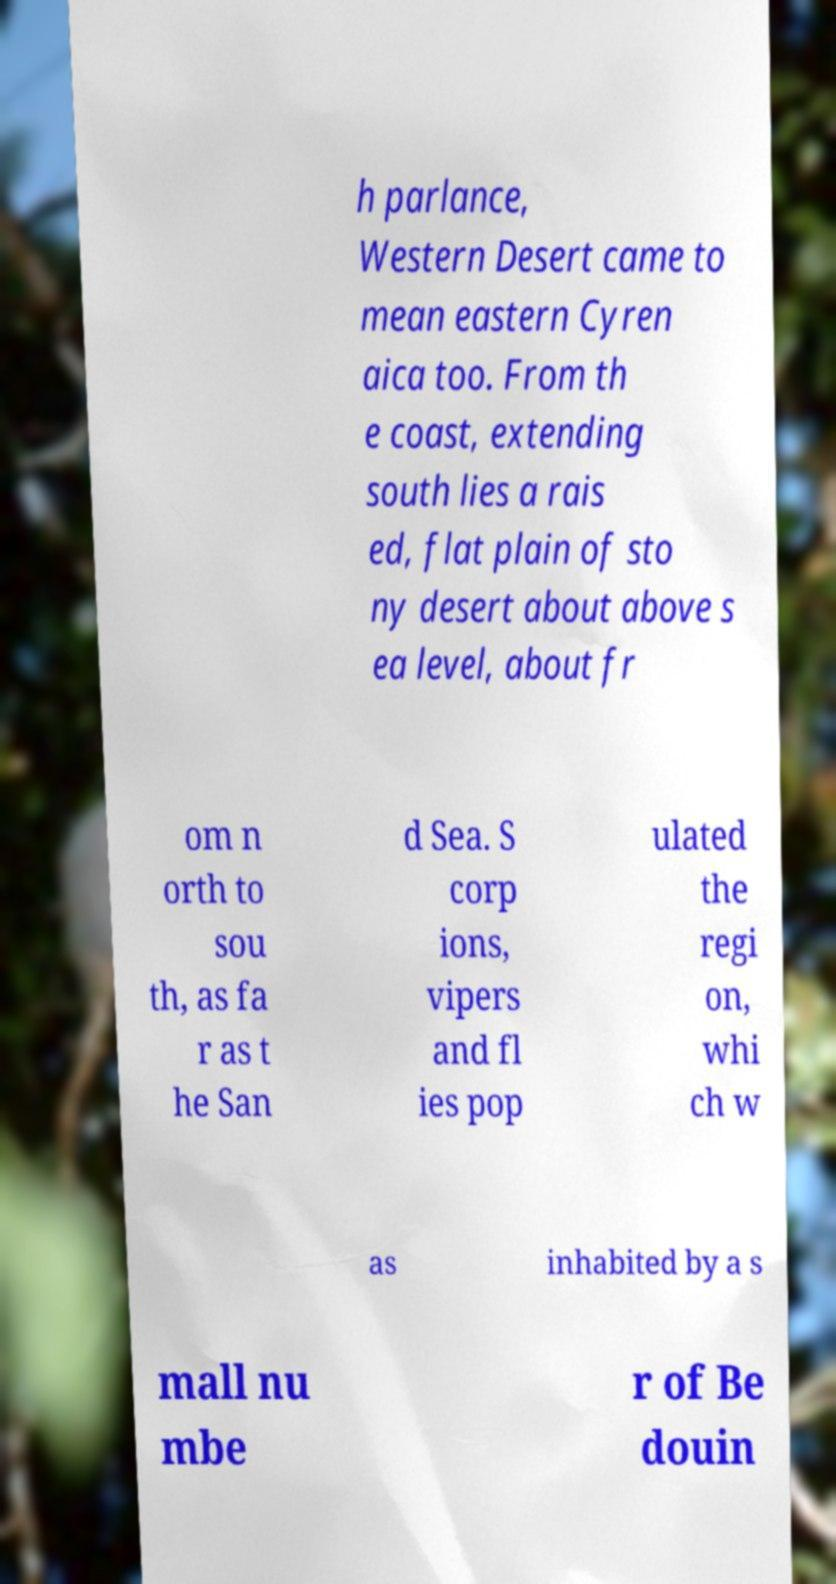Could you extract and type out the text from this image? h parlance, Western Desert came to mean eastern Cyren aica too. From th e coast, extending south lies a rais ed, flat plain of sto ny desert about above s ea level, about fr om n orth to sou th, as fa r as t he San d Sea. S corp ions, vipers and fl ies pop ulated the regi on, whi ch w as inhabited by a s mall nu mbe r of Be douin 